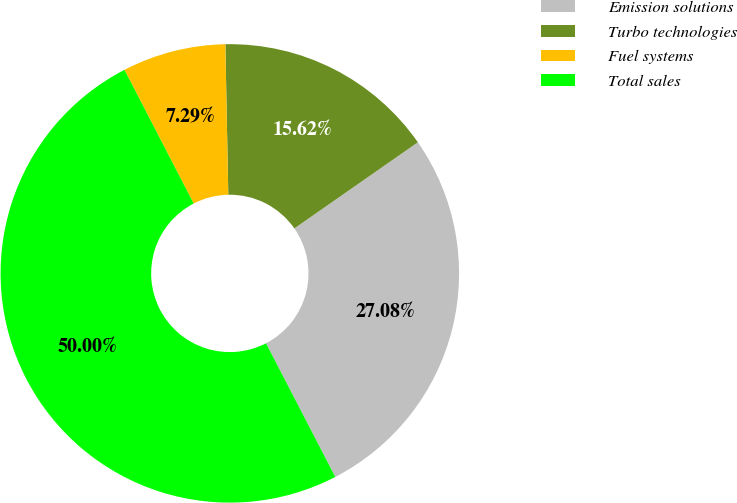Convert chart to OTSL. <chart><loc_0><loc_0><loc_500><loc_500><pie_chart><fcel>Emission solutions<fcel>Turbo technologies<fcel>Fuel systems<fcel>Total sales<nl><fcel>27.08%<fcel>15.62%<fcel>7.29%<fcel>50.0%<nl></chart> 